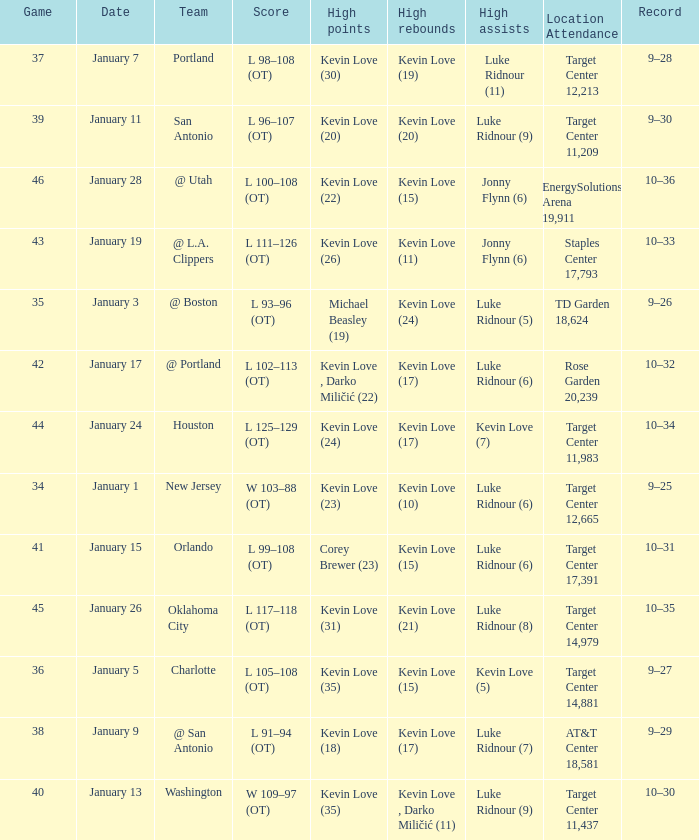What is the date for the game 35? January 3. 